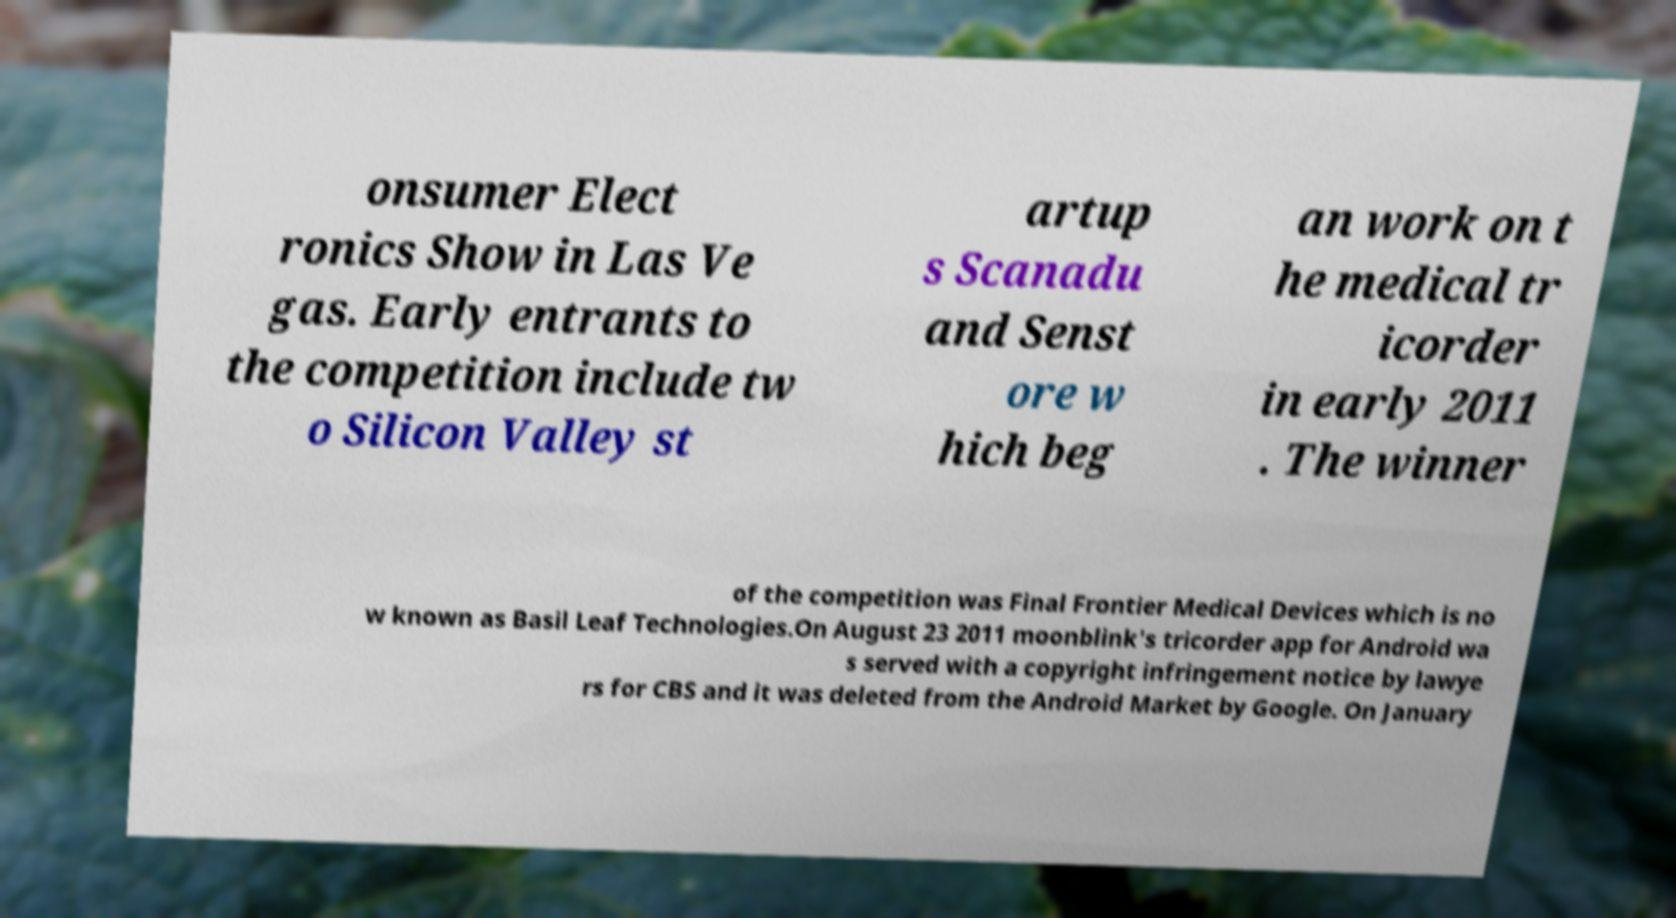Can you read and provide the text displayed in the image?This photo seems to have some interesting text. Can you extract and type it out for me? onsumer Elect ronics Show in Las Ve gas. Early entrants to the competition include tw o Silicon Valley st artup s Scanadu and Senst ore w hich beg an work on t he medical tr icorder in early 2011 . The winner of the competition was Final Frontier Medical Devices which is no w known as Basil Leaf Technologies.On August 23 2011 moonblink's tricorder app for Android wa s served with a copyright infringement notice by lawye rs for CBS and it was deleted from the Android Market by Google. On January 